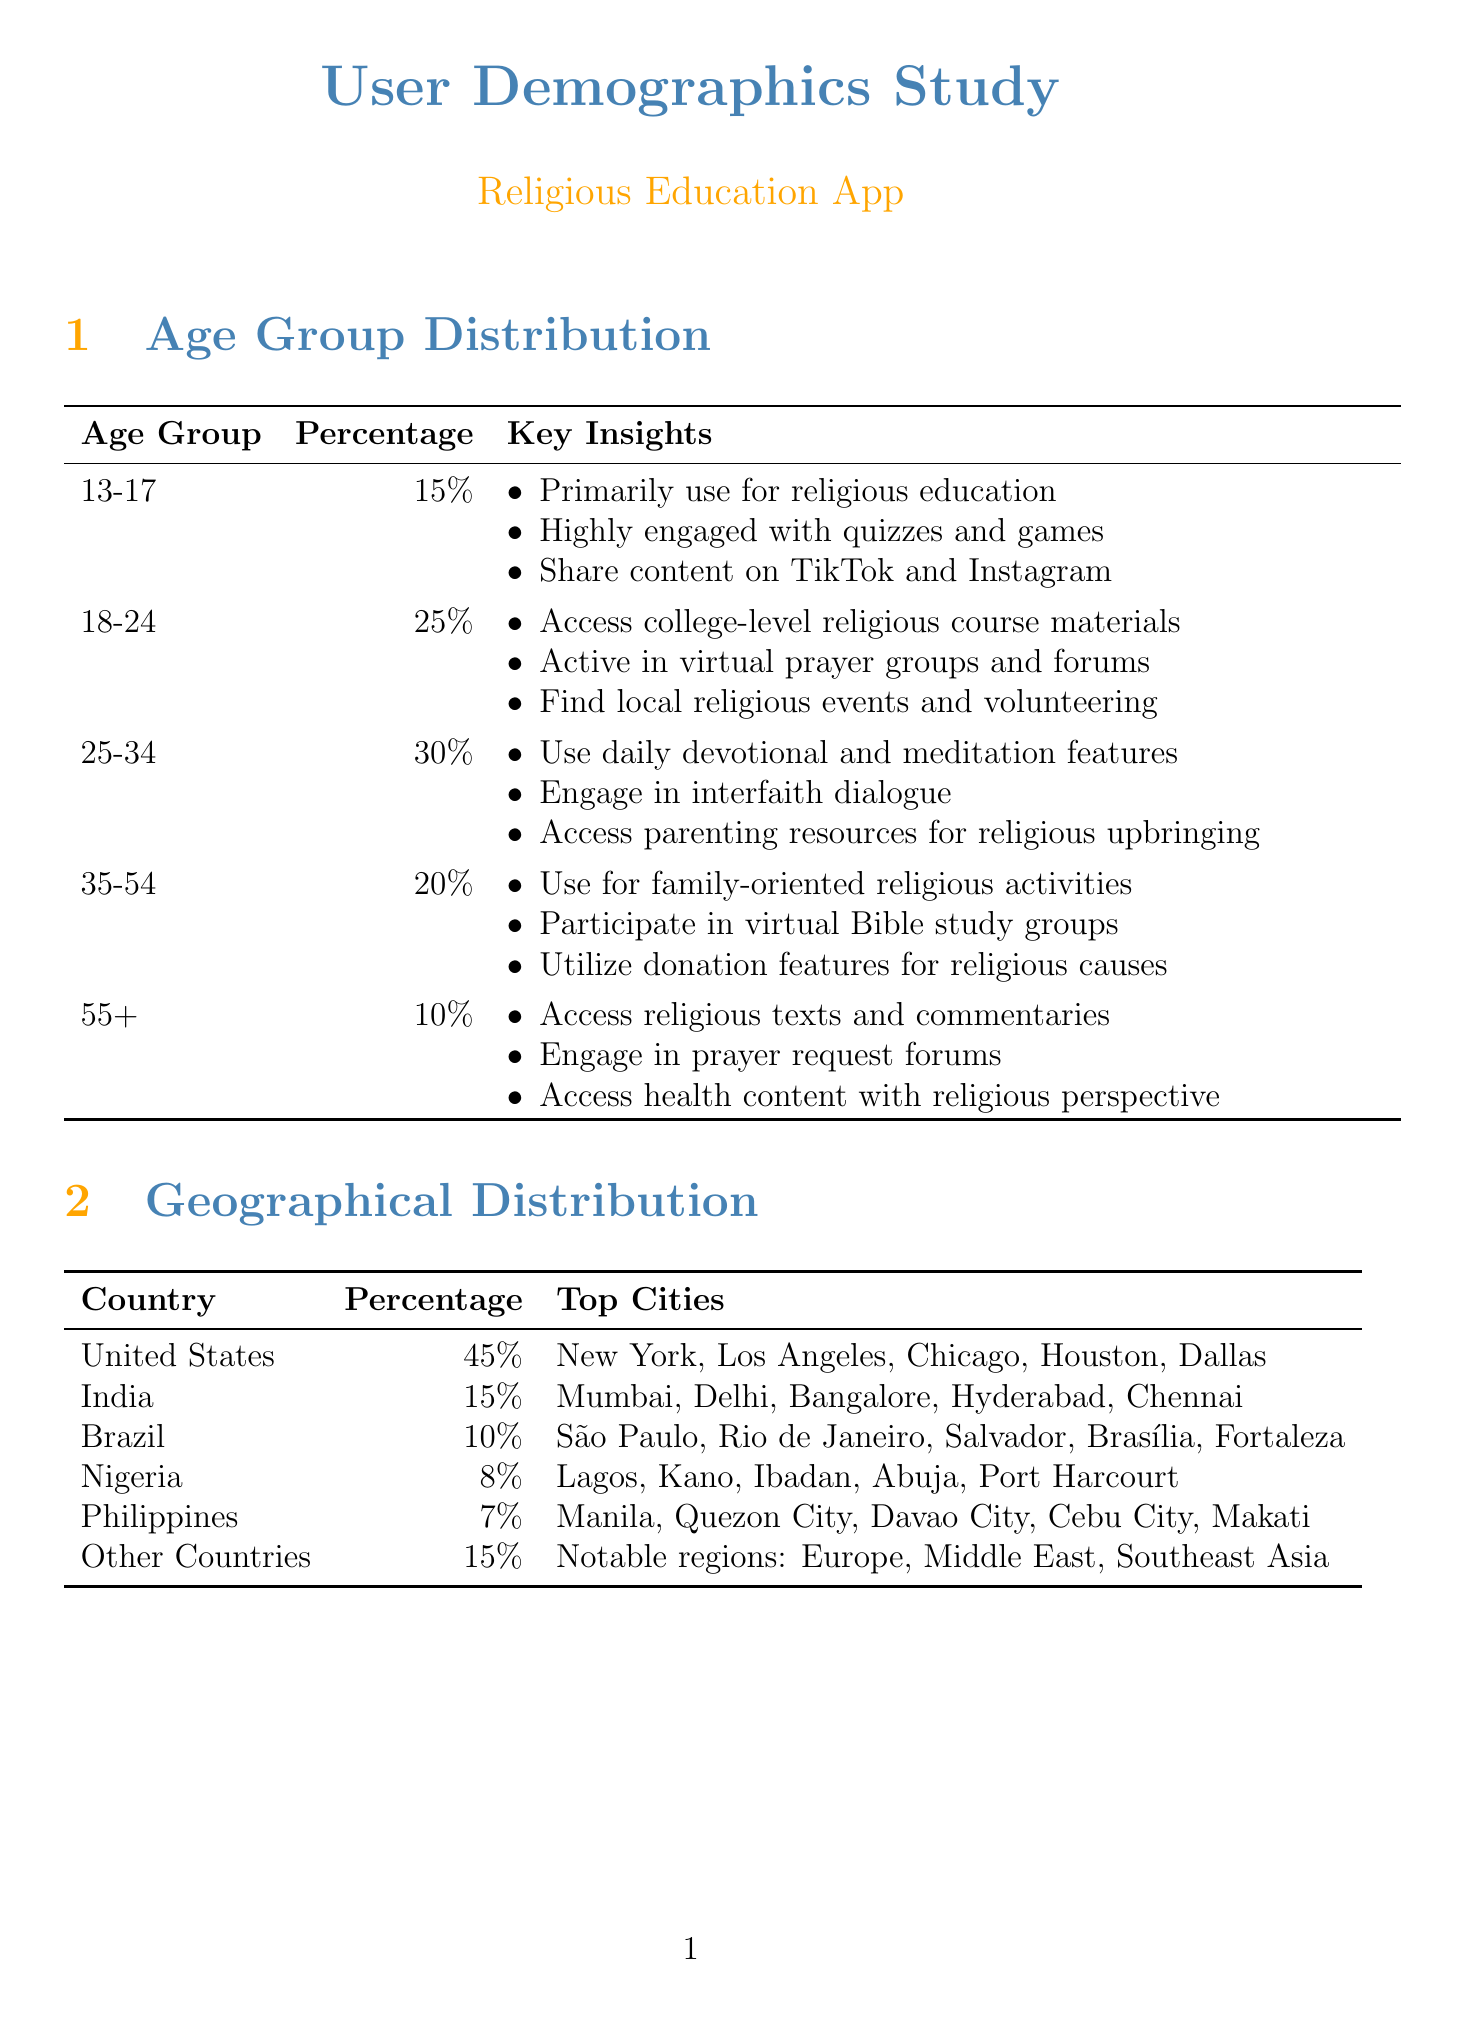What is the percentage of users aged 25-34? The percentage of users aged 25-34 is stated in the document as 30%.
Answer: 30% What are the top five cities in the United States where users are located? The document provides the top cities in the United States as New York, Los Angeles, Chicago, Houston, and Dallas.
Answer: New York, Los Angeles, Chicago, Houston, Dallas What is the average daily active users? The document reports the average daily active users as 500,000.
Answer: 500,000 Which religious affiliation has the highest percentage among users? The document indicates that Christianity has the highest percentage of 55%.
Answer: Christianity What is the 30-day retention rate? The document specifies the 30-day retention rate as 75%.
Answer: 75% How much percentage of users are non-religious or seeking? The document states that 1% of users are non-religious or seeking.
Answer: 1% What key features are most popular among users? The document lists daily devotionals, virtual prayer rooms, and religious text study guides among the most popular features.
Answer: Daily devotionals, virtual prayer rooms, religious text study guides Which acquisition channel has the highest percentage? The document shows that organic search is the highest acquisition channel at 35%.
Answer: Organic Search What percentage of users are from India? The document indicates that 15% of users are from India.
Answer: 15% 